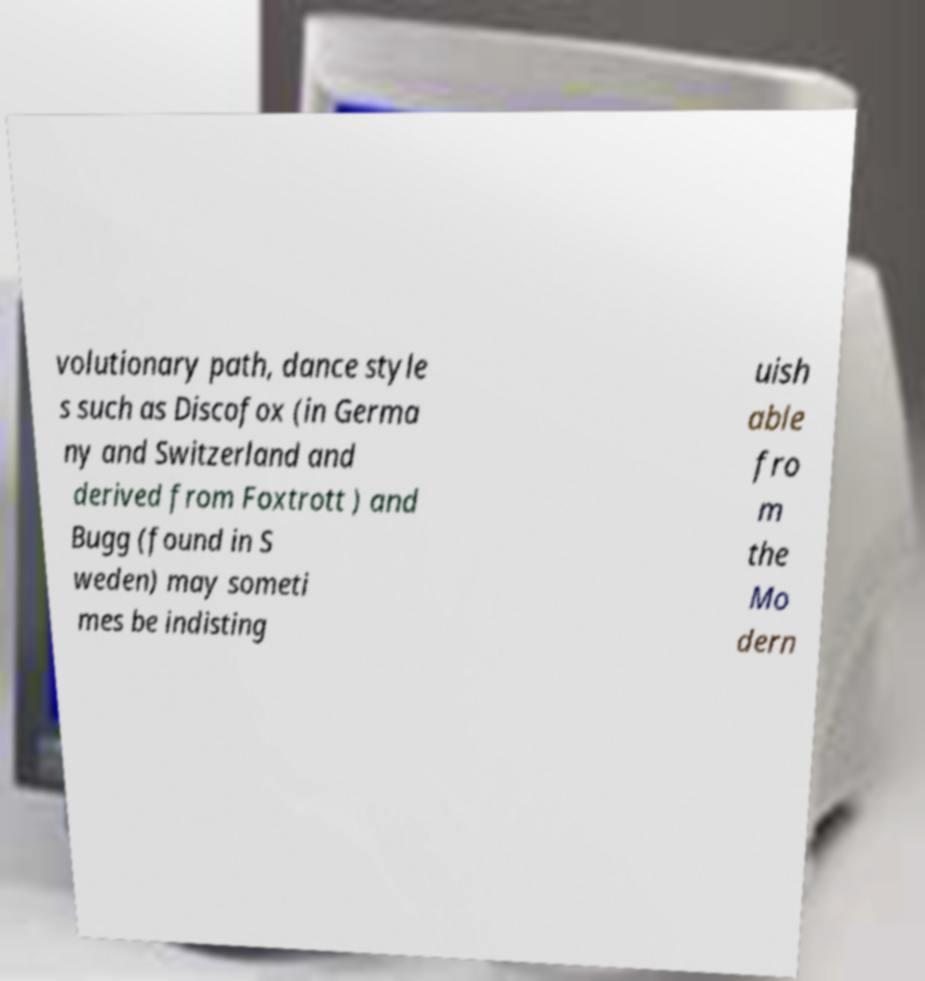Please identify and transcribe the text found in this image. volutionary path, dance style s such as Discofox (in Germa ny and Switzerland and derived from Foxtrott ) and Bugg (found in S weden) may someti mes be indisting uish able fro m the Mo dern 